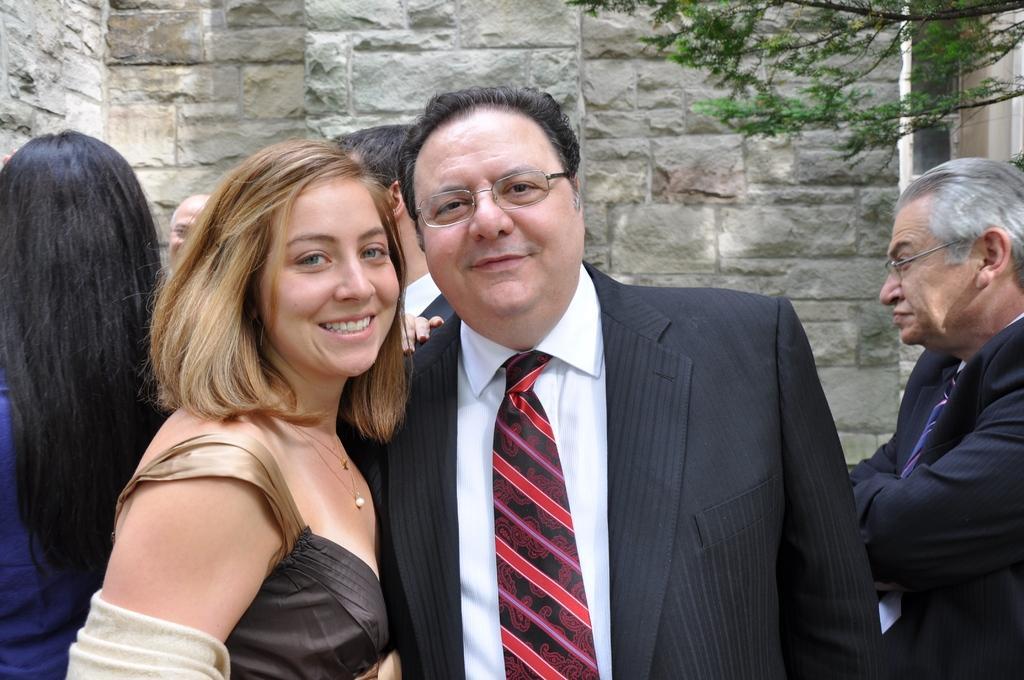How would you summarize this image in a sentence or two? In this image there are two persons standing with a smile on their face, behind them there are other few people standing. In the background there is a tree and a wall. 